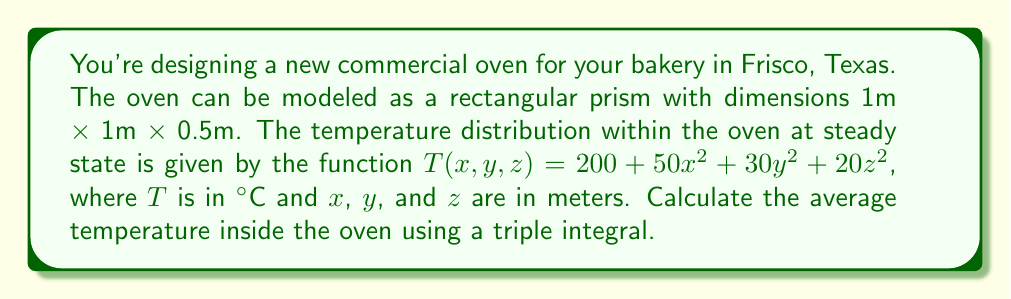Solve this math problem. To find the average temperature inside the oven, we need to:

1. Set up a triple integral to calculate the total heat over the volume.
2. Divide the result by the volume of the oven.

Step 1: Set up the triple integral
The temperature distribution is given by:
$$T(x,y,z) = 200 + 50x^2 + 30y^2 + 20z^2$$

The triple integral for the total heat is:
$$\iiint_V T(x,y,z) \, dV = \int_0^{0.5} \int_0^1 \int_0^1 (200 + 50x^2 + 30y^2 + 20z^2) \, dx \, dy \, dz$$

Step 2: Evaluate the triple integral
$$\begin{align*}
&= \int_0^{0.5} \int_0^1 \left[200x + \frac{50}{3}x^3 + 30xy^2 + 20xz^2\right]_0^1 \, dy \, dz \\
&= \int_0^{0.5} \int_0^1 \left(200 + \frac{50}{3} + 30y^2 + 20z^2\right) \, dy \, dz \\
&= \int_0^{0.5} \left[200y + \frac{50}{3}y + 10y^3 + 20yz^2\right]_0^1 \, dz \\
&= \int_0^{0.5} \left(200 + \frac{50}{3} + 10 + 20z^2\right) \, dz \\
&= \left[200z + \frac{50}{3}z + 10z + \frac{20}{3}z^3\right]_0^{0.5} \\
&= 105 + \frac{25}{6} + 5 + \frac{5}{12} = \frac{2605}{24}
\end{align*}$$

Step 3: Calculate the volume of the oven
$$V = 1 \times 1 \times 0.5 = 0.5 \text{ m}^3$$

Step 4: Calculate the average temperature
$$T_{avg} = \frac{\text{Total Heat}}{\text{Volume}} = \frac{2605/24}{0.5} = \frac{2605}{12} \approx 217.08 \text{ °C}$$
Answer: $\frac{2605}{12}$ °C or approximately 217.08 °C 